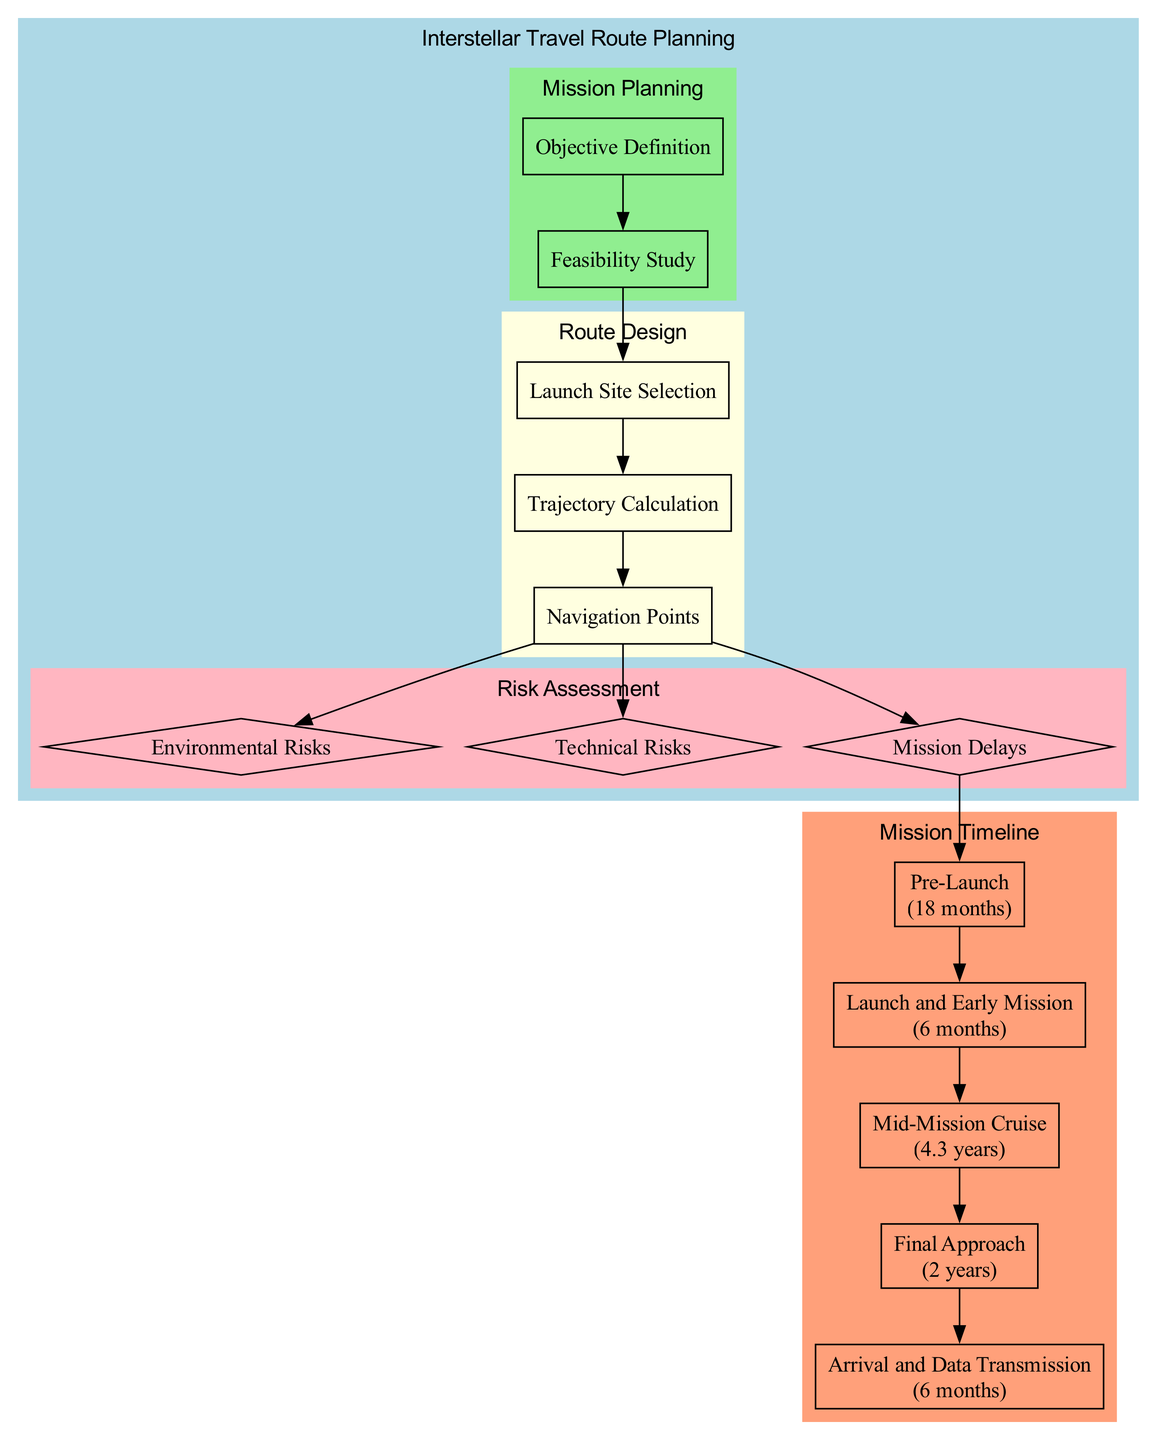What are the two primary components of Mission Planning? The diagram shows two nodes under the "Mission Planning" cluster: "Objective Definition" and "Feasibility Study". These are the main components that outline the mission objectives and assess the technological requirements.
Answer: Objective Definition, Feasibility Study How long is the "Pre-Launch" phase? The diagram indicates that the "Pre-Launch" phase has a duration of "18 months", clearly displayed inside the corresponding node.
Answer: 18 months What node connects "Trajectory Calculation" and "Navigation Points"? According to the diagram, the "Trajectory Calculation" node is connected to the "Navigation Points" node, as indicated by a direct edge between them.
Answer: Navigation Points What are the three activities in the "Mid-Mission Cruise"? The "Mid-Mission Cruise" phase has three specific activities listed: "Navigating the asteroid belt", "Deep space scientific experiments", and "Routine system maintenance".
Answer: Navigating the asteroid belt, Deep space scientific experiments, Routine system maintenance Which phase comes after "Launch and Early Mission"? Following the "Launch and Early Mission" phase, which is listed with a duration of "6 months", the diagram indicates the next phase is "Mid-Mission Cruise", lasting "4.3 years".
Answer: Mid-Mission Cruise What type of risks are associated with "Radiation Exposure"? The "Radiation Exposure" is listed under the "Environmental Risks" section of the "Risk Assessment" cluster, indicating that this type of risk is categorized as environmental.
Answer: Environmental Risks Which two phases have a duration of less than one year? The durations for "Launch and Early Mission" (6 months) and "Arrival and Data Transmission" (6 months) are both less than one year, as shown in the timeline section of the diagram.
Answer: Launch and Early Mission, Arrival and Data Transmission How many activities are listed for the "Final Approach" phase? There are three specific activities outlined in the "Final Approach" phase, which are visible within the corresponding node of the diagram.
Answer: 3 What leads to the identification of "Mission Delays"? The diagram indicates that "Mission Delays" are identified as a potential outcome stemming from "Navigation Points", linking the concerns related to delays with the upcoming phases.
Answer: Navigation Points 